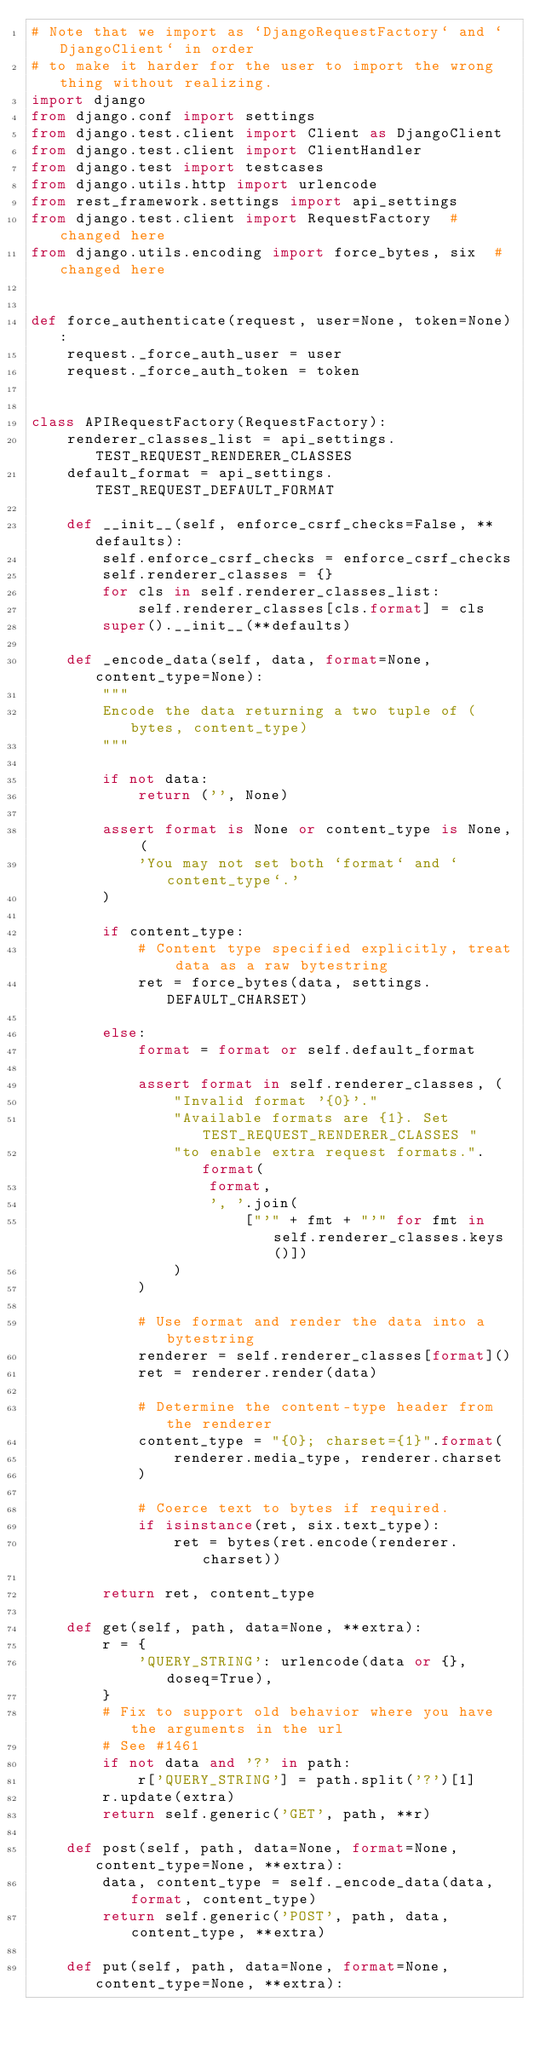Convert code to text. <code><loc_0><loc_0><loc_500><loc_500><_Python_># Note that we import as `DjangoRequestFactory` and `DjangoClient` in order
# to make it harder for the user to import the wrong thing without realizing.
import django
from django.conf import settings
from django.test.client import Client as DjangoClient
from django.test.client import ClientHandler
from django.test import testcases
from django.utils.http import urlencode
from rest_framework.settings import api_settings
from django.test.client import RequestFactory  # changed here
from django.utils.encoding import force_bytes, six  # changed here


def force_authenticate(request, user=None, token=None):
    request._force_auth_user = user
    request._force_auth_token = token


class APIRequestFactory(RequestFactory):
    renderer_classes_list = api_settings.TEST_REQUEST_RENDERER_CLASSES
    default_format = api_settings.TEST_REQUEST_DEFAULT_FORMAT

    def __init__(self, enforce_csrf_checks=False, **defaults):
        self.enforce_csrf_checks = enforce_csrf_checks
        self.renderer_classes = {}
        for cls in self.renderer_classes_list:
            self.renderer_classes[cls.format] = cls
        super().__init__(**defaults)

    def _encode_data(self, data, format=None, content_type=None):
        """
        Encode the data returning a two tuple of (bytes, content_type)
        """

        if not data:
            return ('', None)

        assert format is None or content_type is None, (
            'You may not set both `format` and `content_type`.'
        )

        if content_type:
            # Content type specified explicitly, treat data as a raw bytestring
            ret = force_bytes(data, settings.DEFAULT_CHARSET)

        else:
            format = format or self.default_format

            assert format in self.renderer_classes, (
                "Invalid format '{0}'."
                "Available formats are {1}. Set TEST_REQUEST_RENDERER_CLASSES "
                "to enable extra request formats.".format(
                    format,
                    ', '.join(
                        ["'" + fmt + "'" for fmt in self.renderer_classes.keys()])
                )
            )

            # Use format and render the data into a bytestring
            renderer = self.renderer_classes[format]()
            ret = renderer.render(data)

            # Determine the content-type header from the renderer
            content_type = "{0}; charset={1}".format(
                renderer.media_type, renderer.charset
            )

            # Coerce text to bytes if required.
            if isinstance(ret, six.text_type):
                ret = bytes(ret.encode(renderer.charset))

        return ret, content_type

    def get(self, path, data=None, **extra):
        r = {
            'QUERY_STRING': urlencode(data or {}, doseq=True),
        }
        # Fix to support old behavior where you have the arguments in the url
        # See #1461
        if not data and '?' in path:
            r['QUERY_STRING'] = path.split('?')[1]
        r.update(extra)
        return self.generic('GET', path, **r)

    def post(self, path, data=None, format=None, content_type=None, **extra):
        data, content_type = self._encode_data(data, format, content_type)
        return self.generic('POST', path, data, content_type, **extra)

    def put(self, path, data=None, format=None, content_type=None, **extra):</code> 